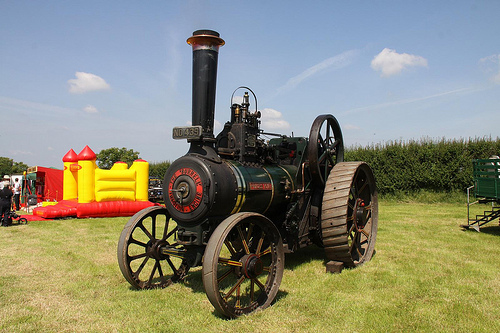<image>
Is there a wheel to the right of the wheel? Yes. From this viewpoint, the wheel is positioned to the right side relative to the wheel. 